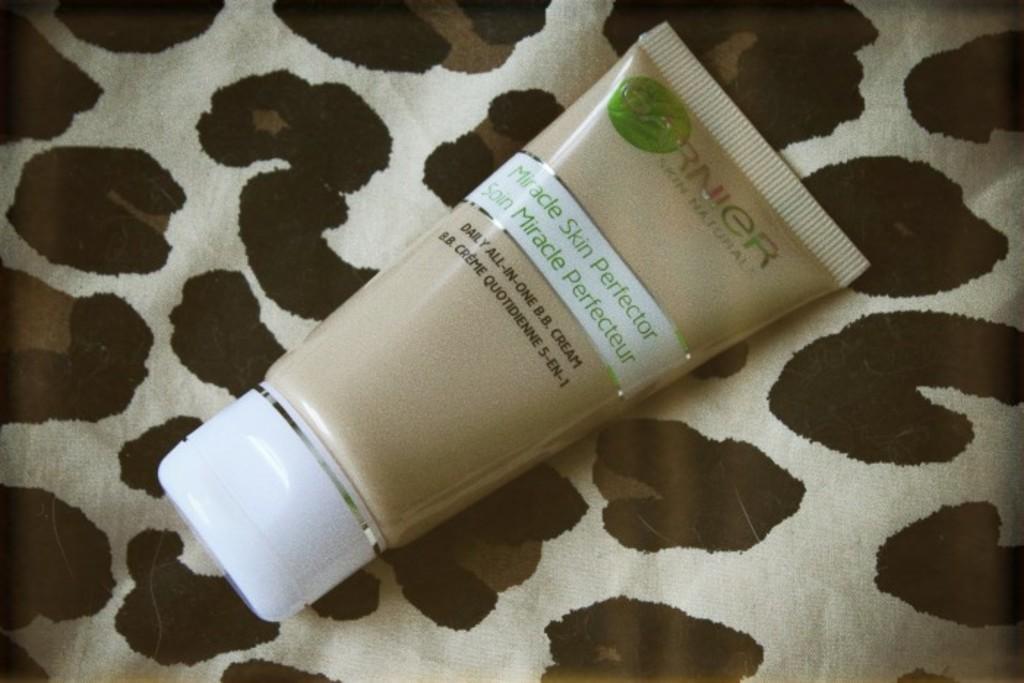What is the brand name on this skin perfector?
Offer a terse response. Garnier. What is the name of this product?
Give a very brief answer. Miracle skin perfector. 